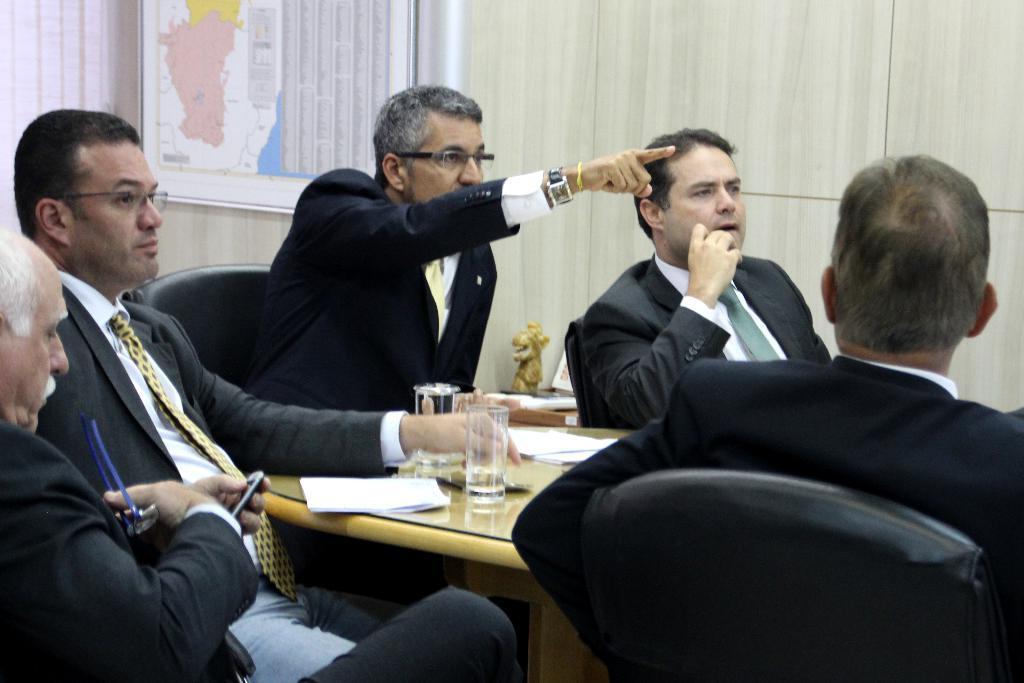Please provide a concise description of this image. In this image we can see few people sitting on chairs and there is a table with papers, glasses and some other objects and we can see a poster with some text and map and the poster is attached to the wall. 